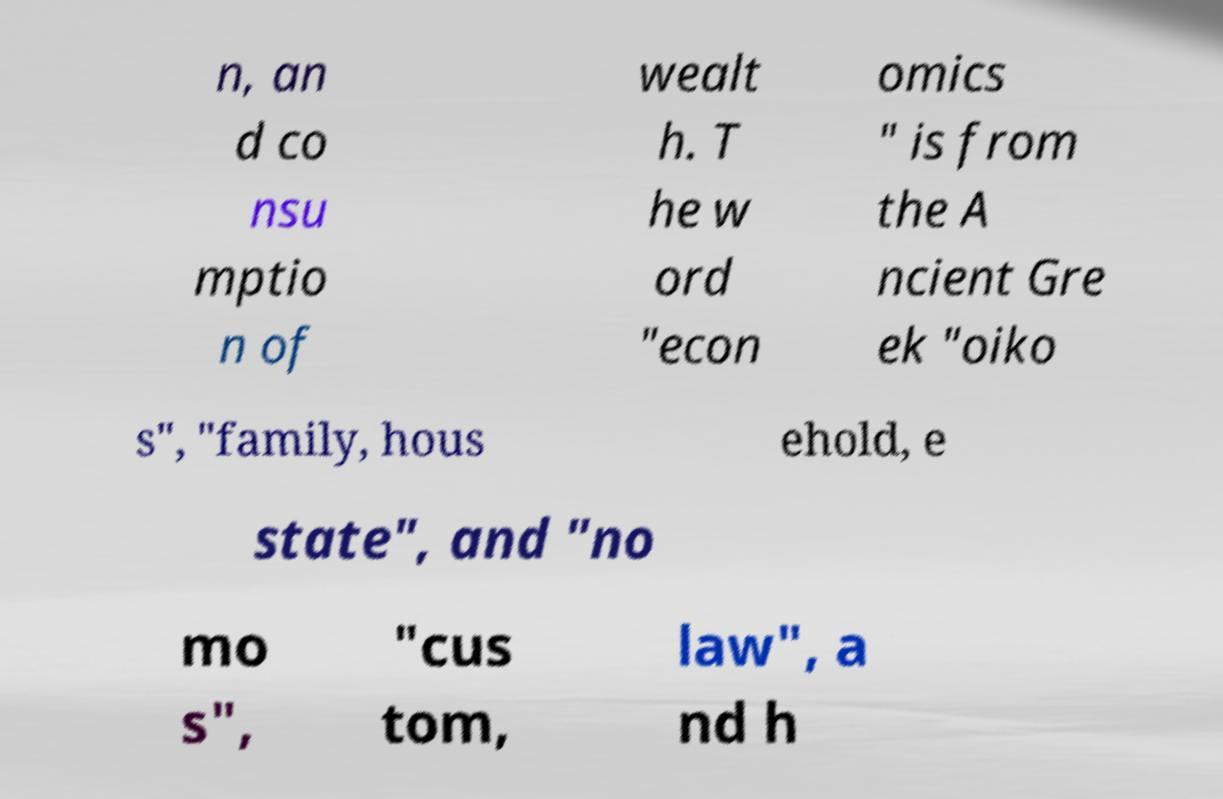Could you assist in decoding the text presented in this image and type it out clearly? n, an d co nsu mptio n of wealt h. T he w ord "econ omics " is from the A ncient Gre ek "oiko s", "family, hous ehold, e state", and "no mo s", "cus tom, law", a nd h 